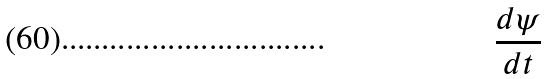Convert formula to latex. <formula><loc_0><loc_0><loc_500><loc_500>\frac { d \psi } { d t }</formula> 